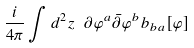<formula> <loc_0><loc_0><loc_500><loc_500>\frac { i } { 4 \pi } \int d ^ { 2 } z \ \partial \varphi ^ { a } \bar { \partial } \varphi ^ { b } b _ { b a } [ \varphi ]</formula> 